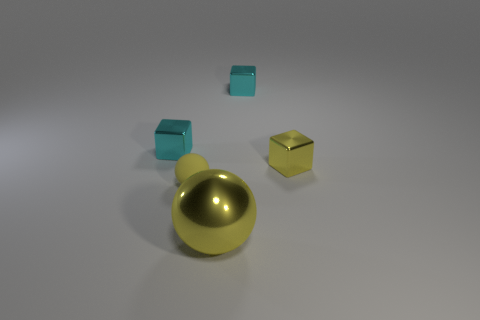Is there any other thing that has the same size as the yellow shiny ball?
Your answer should be very brief. No. Is the small yellow thing that is to the left of the yellow cube made of the same material as the yellow block?
Offer a very short reply. No. What number of things are either large objects or yellow shiny things that are behind the yellow rubber sphere?
Your response must be concise. 2. What color is the ball that is made of the same material as the yellow cube?
Provide a succinct answer. Yellow. What number of tiny cubes are the same material as the small sphere?
Ensure brevity in your answer.  0. How many blocks are there?
Provide a short and direct response. 3. There is a small object in front of the tiny yellow shiny block; does it have the same color as the shiny thing left of the large yellow ball?
Your response must be concise. No. There is a large metal object; what number of small yellow matte objects are in front of it?
Make the answer very short. 0. What material is the other large object that is the same color as the matte thing?
Your answer should be compact. Metal. Is there another object that has the same shape as the small yellow shiny thing?
Your answer should be very brief. Yes. 